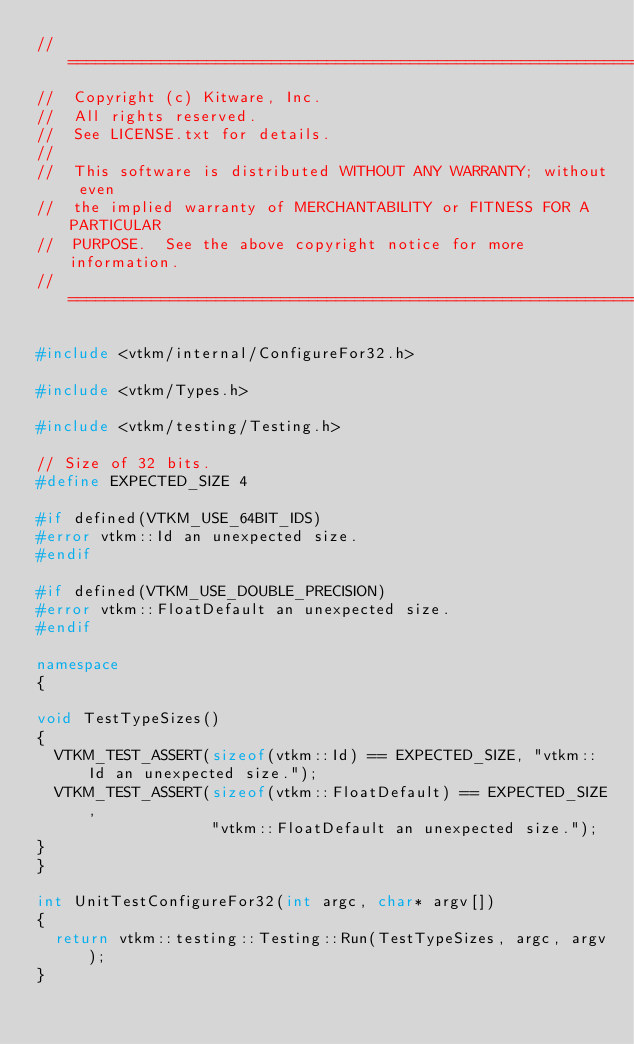Convert code to text. <code><loc_0><loc_0><loc_500><loc_500><_C++_>//============================================================================
//  Copyright (c) Kitware, Inc.
//  All rights reserved.
//  See LICENSE.txt for details.
//
//  This software is distributed WITHOUT ANY WARRANTY; without even
//  the implied warranty of MERCHANTABILITY or FITNESS FOR A PARTICULAR
//  PURPOSE.  See the above copyright notice for more information.
//============================================================================

#include <vtkm/internal/ConfigureFor32.h>

#include <vtkm/Types.h>

#include <vtkm/testing/Testing.h>

// Size of 32 bits.
#define EXPECTED_SIZE 4

#if defined(VTKM_USE_64BIT_IDS)
#error vtkm::Id an unexpected size.
#endif

#if defined(VTKM_USE_DOUBLE_PRECISION)
#error vtkm::FloatDefault an unexpected size.
#endif

namespace
{

void TestTypeSizes()
{
  VTKM_TEST_ASSERT(sizeof(vtkm::Id) == EXPECTED_SIZE, "vtkm::Id an unexpected size.");
  VTKM_TEST_ASSERT(sizeof(vtkm::FloatDefault) == EXPECTED_SIZE,
                   "vtkm::FloatDefault an unexpected size.");
}
}

int UnitTestConfigureFor32(int argc, char* argv[])
{
  return vtkm::testing::Testing::Run(TestTypeSizes, argc, argv);
}
</code> 